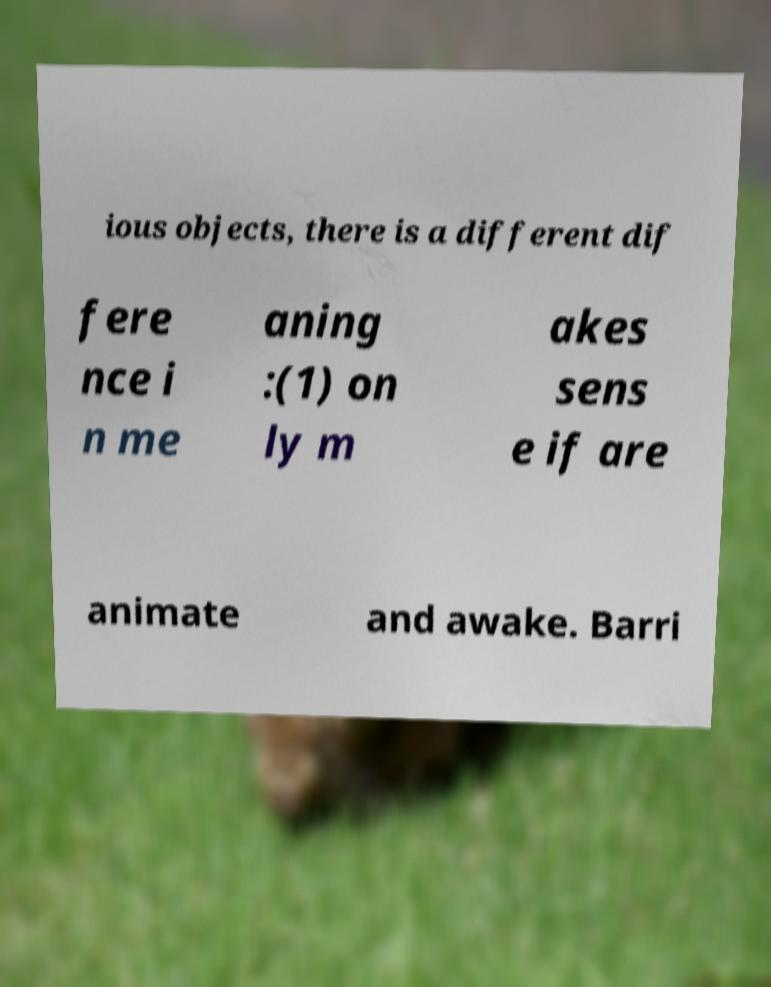Please read and relay the text visible in this image. What does it say? ious objects, there is a different dif fere nce i n me aning :(1) on ly m akes sens e if are animate and awake. Barri 